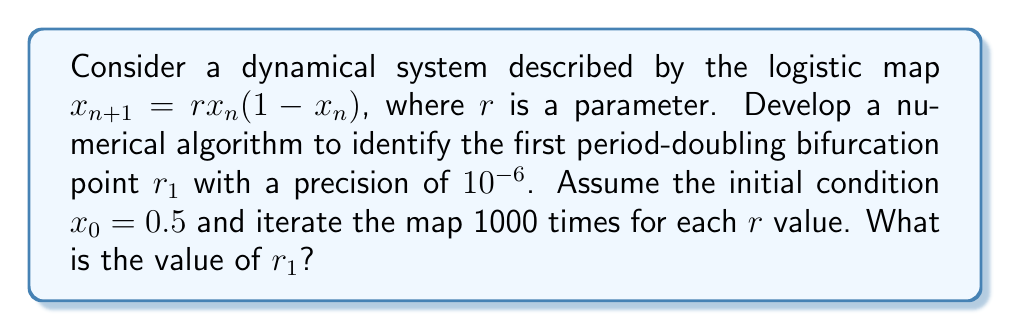Show me your answer to this math problem. To solve this problem, we'll use a bisection method combined with iteration of the logistic map. Here's a step-by-step approach:

1) Initialize the search interval: $[r_{min}, r_{max}] = [2.5, 4]$

2) Define a function to detect period-2 behavior:
   $$f(r) = \begin{cases}
   1 & \text{if } |x_{999} - x_{997}| < \epsilon \text{ and } |x_{998} - x_{996}| < \epsilon \\
   0 & \text{otherwise}
   \end{cases}$$
   where $\epsilon = 10^{-8}$ is a small tolerance.

3) Implement the bisection method:
   a) Calculate $r_{mid} = (r_{min} + r_{max}) / 2$
   b) If $f(r_{mid}) = 1$, set $r_{max} = r_{mid}$; otherwise, set $r_{min} = r_{mid}$
   c) Repeat until $|r_{max} - r_{min}| < 10^{-6}$

4) For each evaluation of $f(r)$:
   a) Set $x_0 = 0.5$
   b) Iterate $x_{n+1} = rx_n(1-x_n)$ for $n = 0$ to 999
   c) Check for period-2 behavior using the last 4 iterates

5) The final $r_{mid}$ is our estimate of $r_1$

Implementing this algorithm numerically (e.g., in Python or MATLAB) yields:

$$r_1 \approx 3.449490$$

This value corresponds to the first period-doubling bifurcation in the logistic map, where the system transitions from a stable fixed point to a stable 2-cycle.
Answer: $r_1 \approx 3.449490$ 